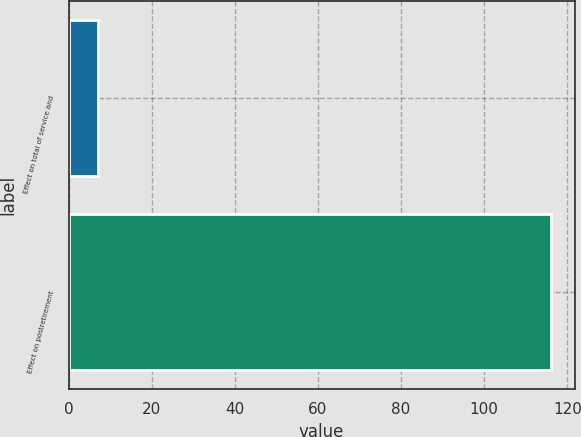Convert chart to OTSL. <chart><loc_0><loc_0><loc_500><loc_500><bar_chart><fcel>Effect on total of service and<fcel>Effect on postretirement<nl><fcel>7<fcel>116<nl></chart> 